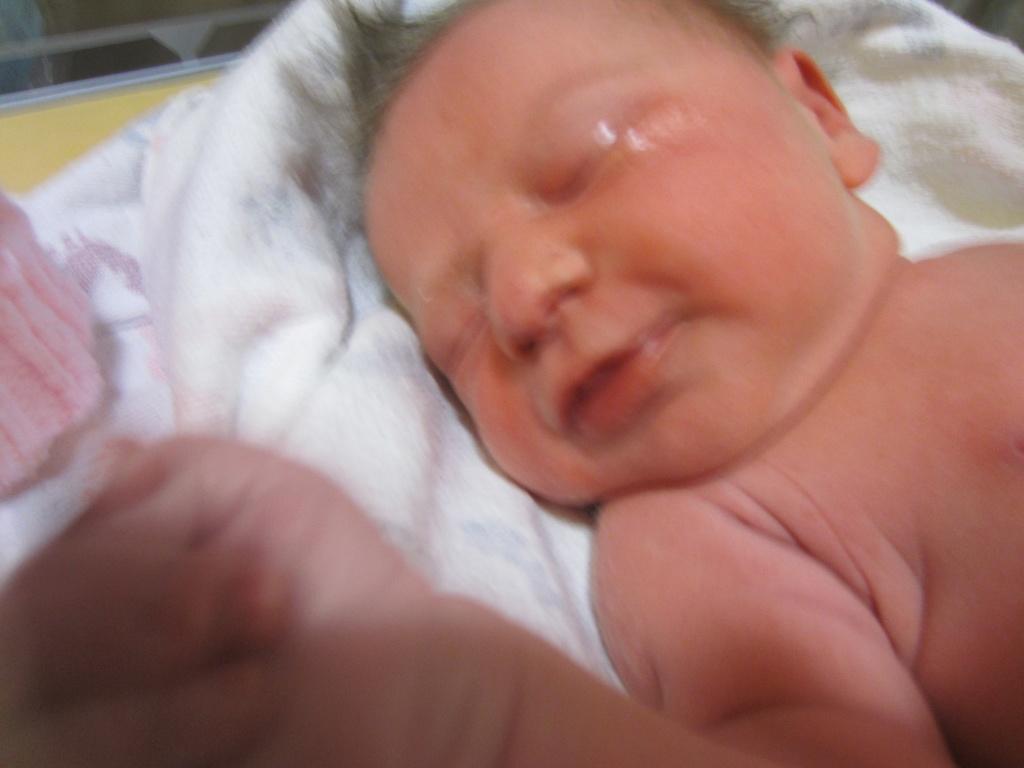Can you describe this image briefly? In this image I can see a baby is lying on a white colored cloth. 